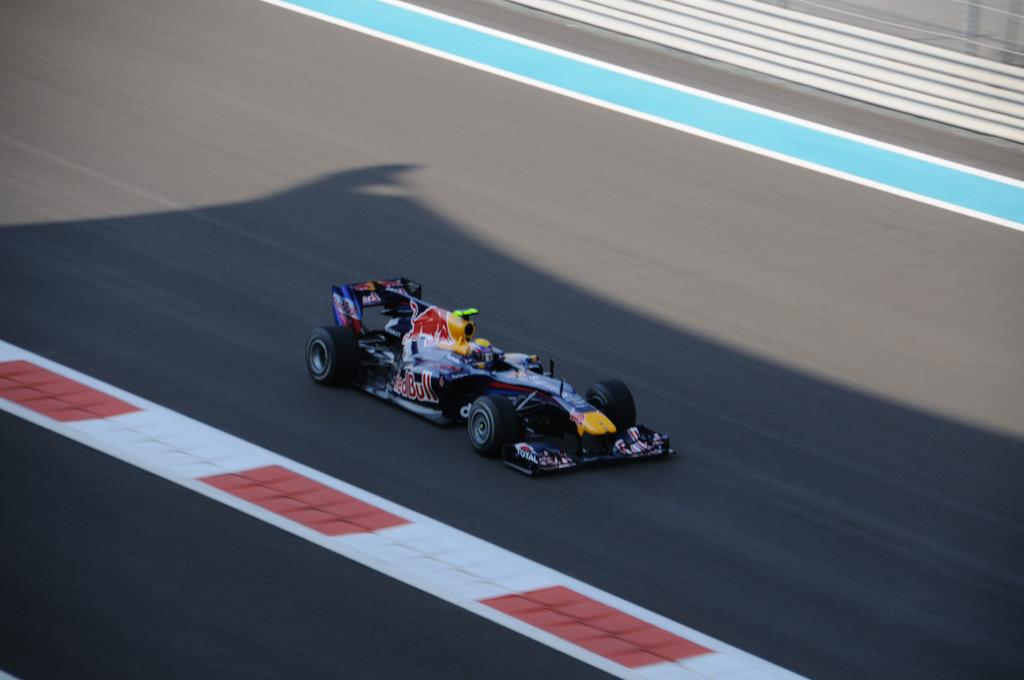What is the main subject of the image? The main subject of the image is a racing car. What is in the middle of the image? There is a road in the middle of the image. Is there anyone inside the racing car? Yes, there is a person in the racing car. Where is the grandfather sitting with the zebra in the image? There is no grandfather or zebra present in the image; it features a racing car on a road with a person inside. What type of throne can be seen in the image? There is no throne present in the image. 